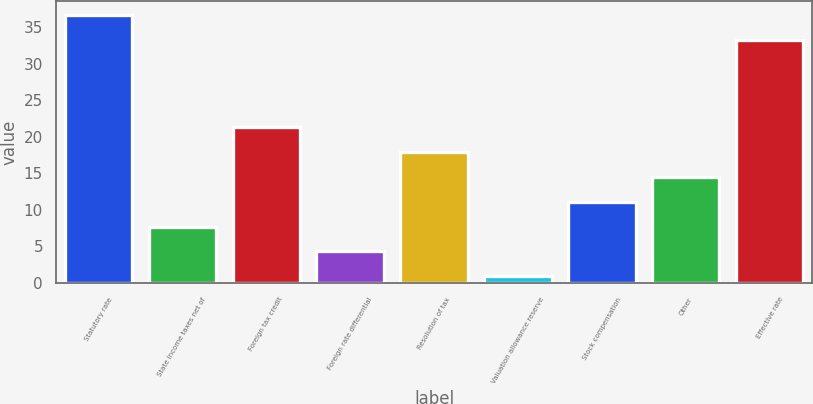<chart> <loc_0><loc_0><loc_500><loc_500><bar_chart><fcel>Statutory rate<fcel>State income taxes net of<fcel>Foreign tax credit<fcel>Foreign rate differential<fcel>Resolution of tax<fcel>Valuation allowance reserve<fcel>Stock compensation<fcel>Other<fcel>Effective rate<nl><fcel>36.71<fcel>7.72<fcel>21.36<fcel>4.31<fcel>17.95<fcel>0.9<fcel>11.13<fcel>14.54<fcel>33.3<nl></chart> 